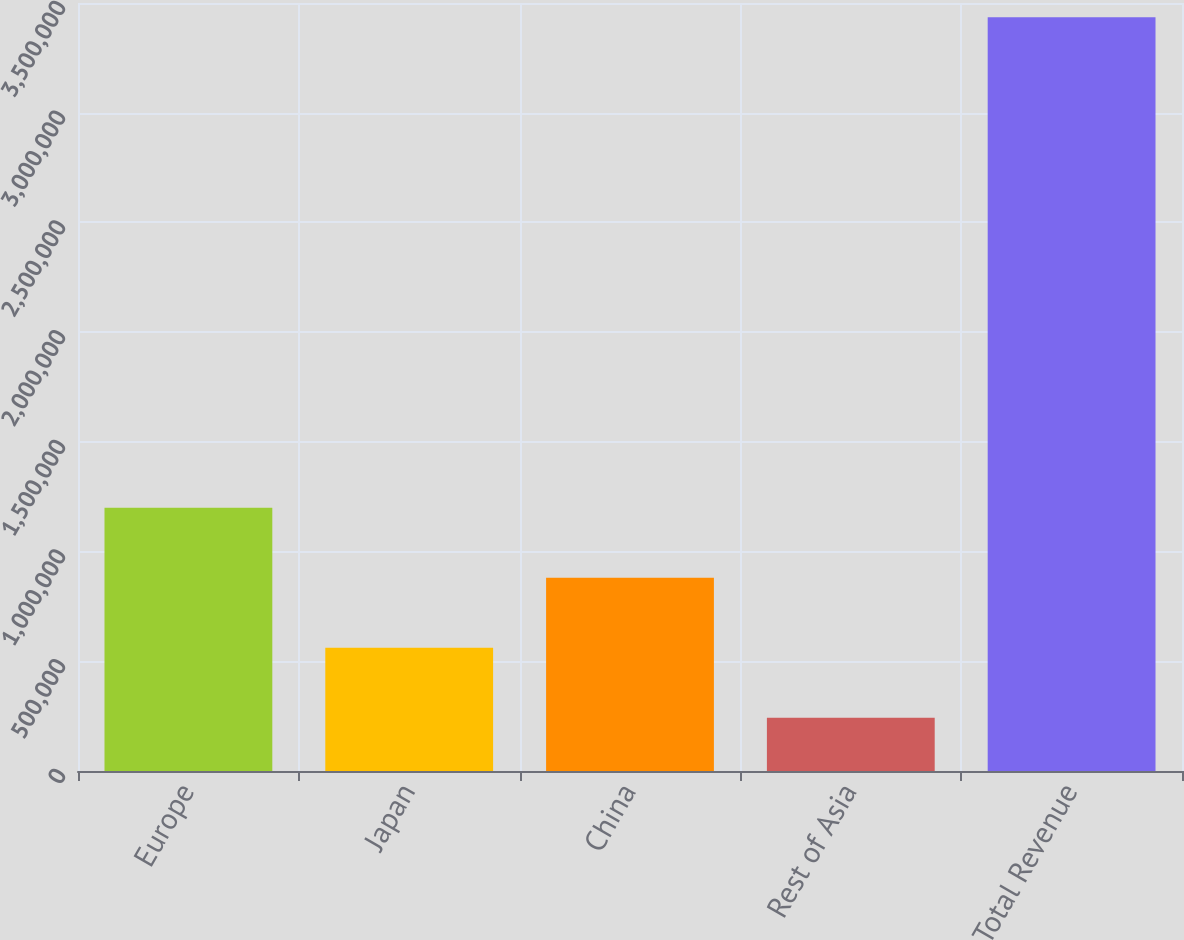<chart> <loc_0><loc_0><loc_500><loc_500><bar_chart><fcel>Europe<fcel>Japan<fcel>China<fcel>Rest of Asia<fcel>Total Revenue<nl><fcel>1.20025e+06<fcel>561723<fcel>880986<fcel>242460<fcel>3.43509e+06<nl></chart> 